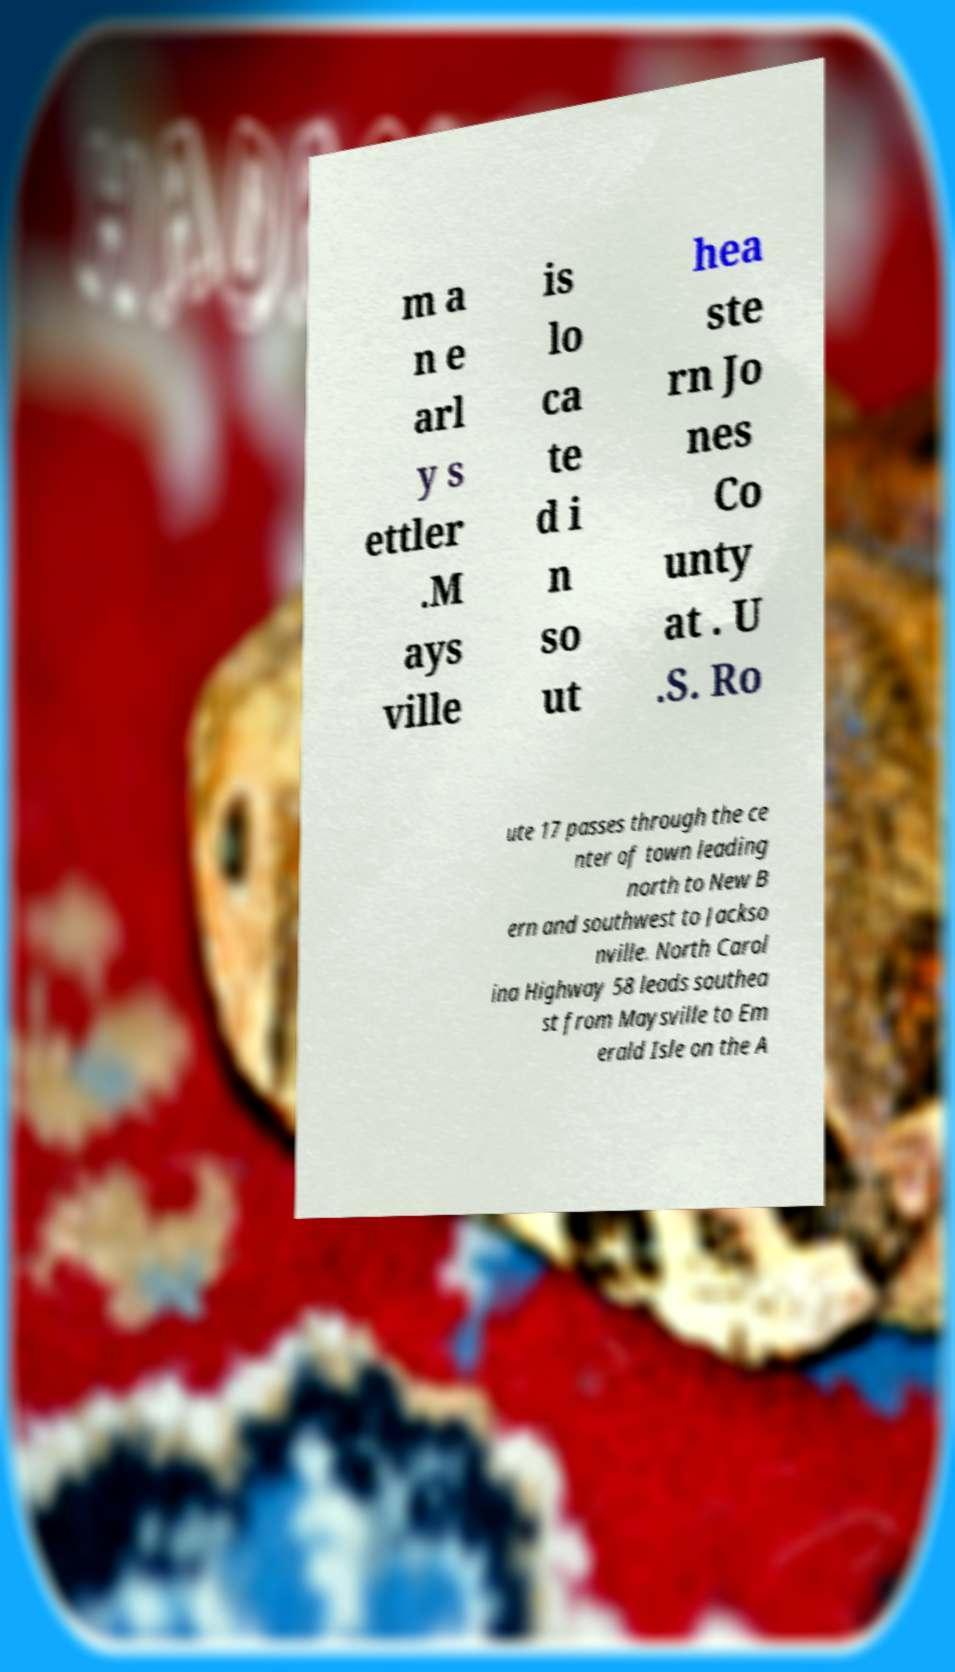I need the written content from this picture converted into text. Can you do that? m a n e arl y s ettler .M ays ville is lo ca te d i n so ut hea ste rn Jo nes Co unty at . U .S. Ro ute 17 passes through the ce nter of town leading north to New B ern and southwest to Jackso nville. North Carol ina Highway 58 leads southea st from Maysville to Em erald Isle on the A 